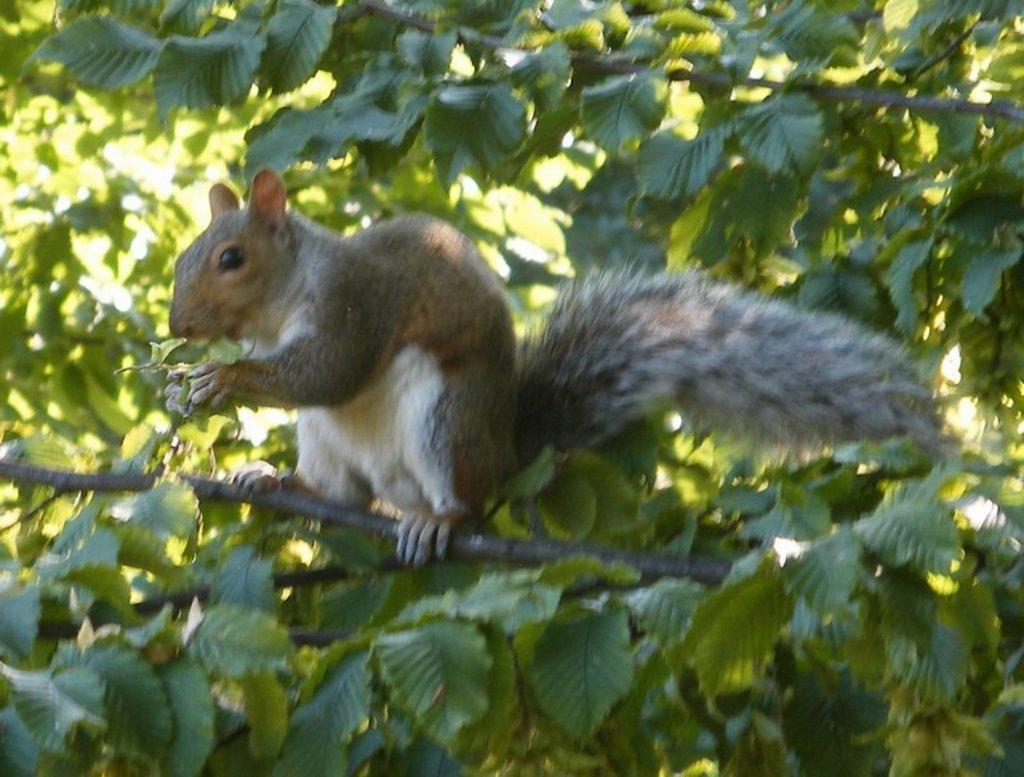How would you summarize this image in a sentence or two? In this picture I can observe a squirrel on the branch of a tree in the middle of the picture. In the background I can observe tree. 